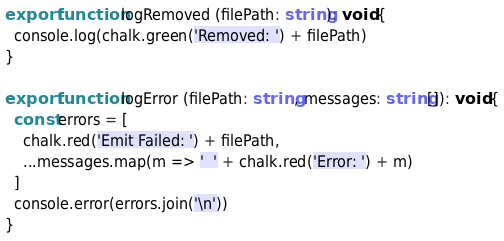Convert code to text. <code><loc_0><loc_0><loc_500><loc_500><_TypeScript_>export function logRemoved (filePath: string): void {
  console.log(chalk.green('Removed: ') + filePath)
}

export function logError (filePath: string, messages: string[]): void {
  const errors = [
    chalk.red('Emit Failed: ') + filePath,
    ...messages.map(m => '  ' + chalk.red('Error: ') + m)
  ]
  console.error(errors.join('\n'))
}
</code> 